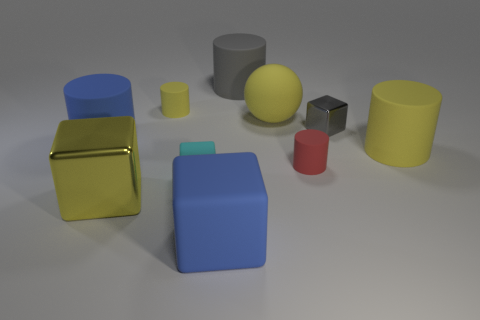Subtract all green spheres. How many yellow cylinders are left? 2 Subtract all yellow rubber cylinders. How many cylinders are left? 3 Subtract all gray cylinders. How many cylinders are left? 4 Subtract all purple cubes. Subtract all gray cylinders. How many cubes are left? 4 Subtract all blocks. How many objects are left? 6 Add 3 yellow rubber objects. How many yellow rubber objects exist? 6 Subtract 0 purple cylinders. How many objects are left? 10 Subtract all large yellow metallic blocks. Subtract all large yellow objects. How many objects are left? 6 Add 6 small objects. How many small objects are left? 10 